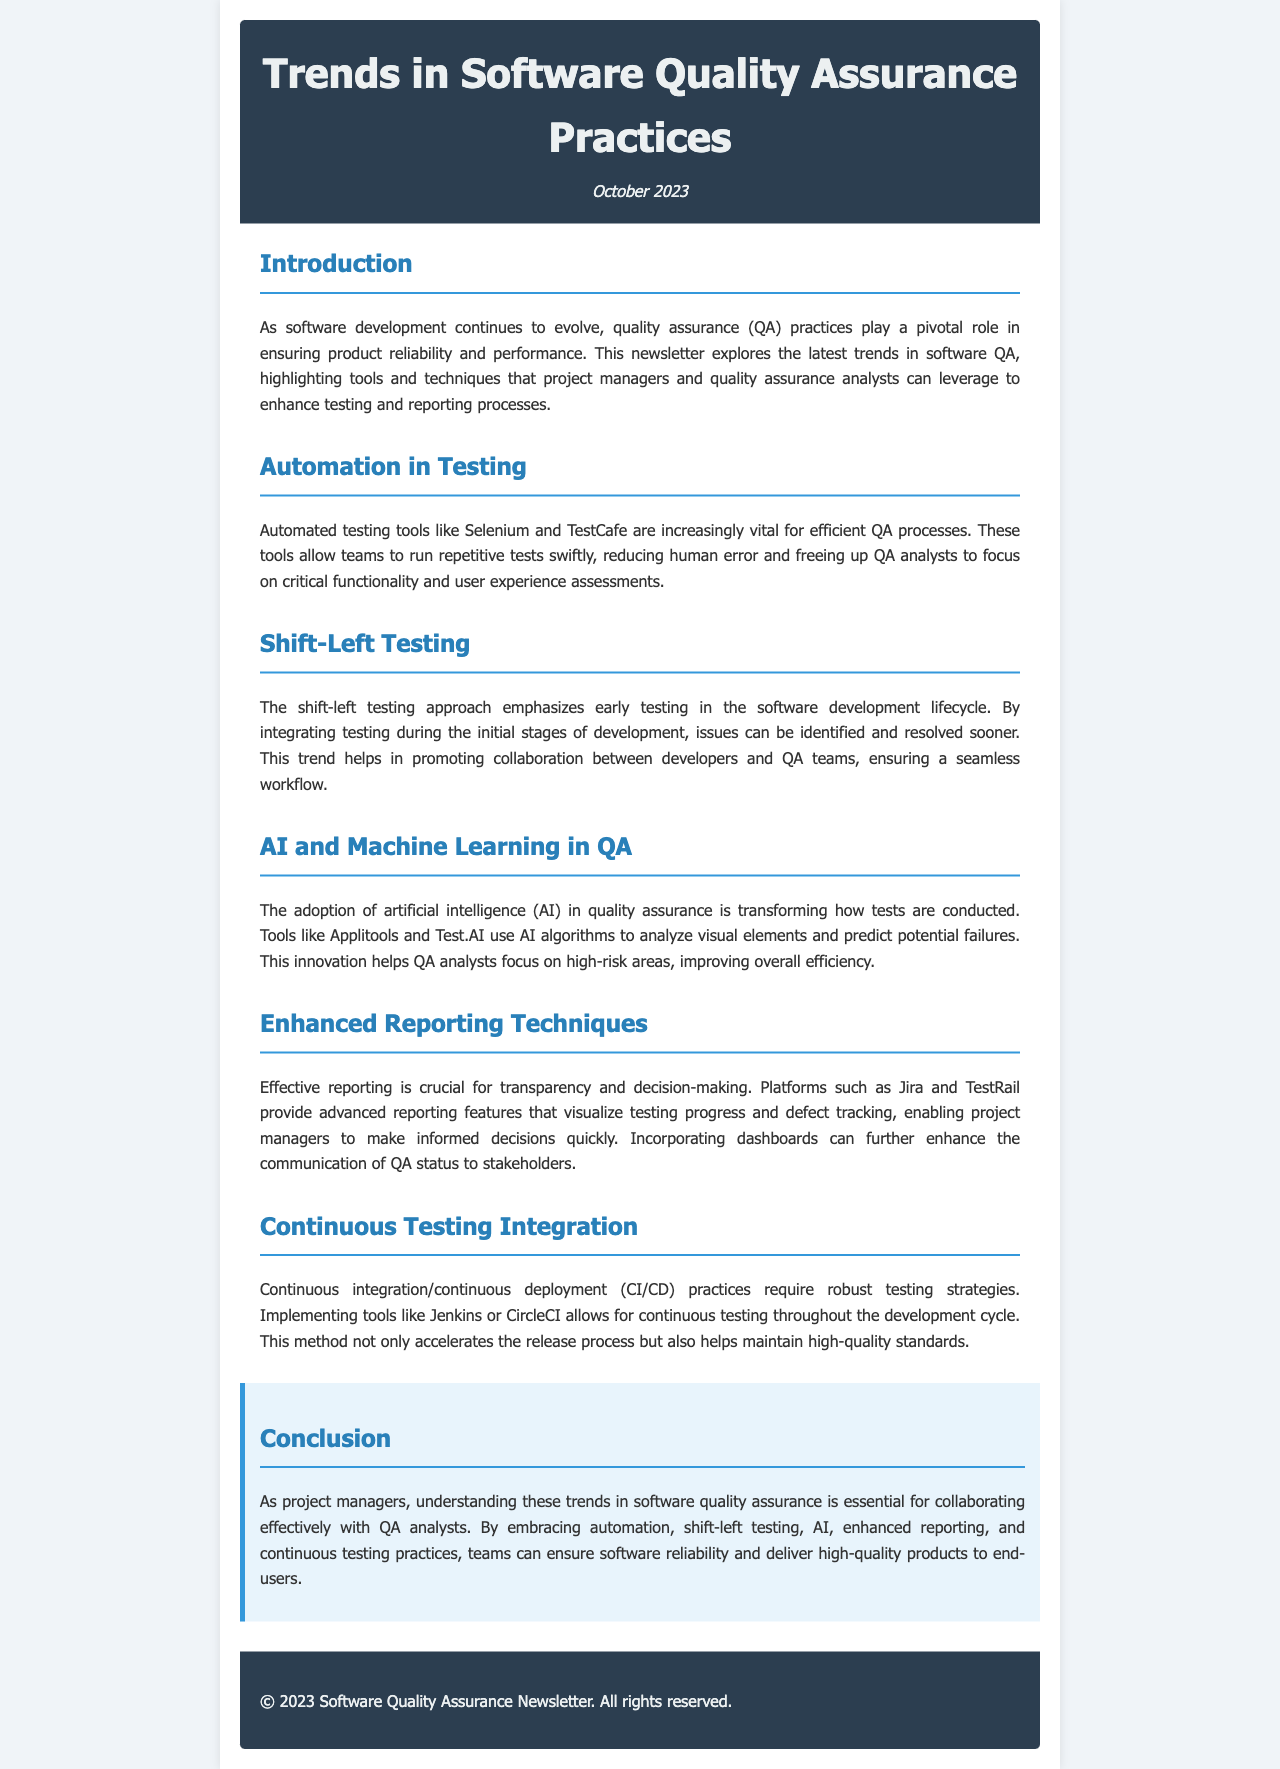What is the title of the newsletter? The title provides the main topic covered in the document, which is "Trends in Software Quality Assurance Practices."
Answer: Trends in Software Quality Assurance Practices When was the newsletter published? The publication date is mentioned in the document as "October 2023."
Answer: October 2023 What testing tools are mentioned for automation? The document lists specific tools that are important for testing automation, namely "Selenium" and "TestCafe."
Answer: Selenium, TestCafe What does the shift-left testing approach emphasize? This approach focuses on early testing in the software development lifecycle according to the document.
Answer: Early testing Which AI tools are highlighted for use in quality assurance? The newsletter specifies tools that utilize AI algorithms, including "Applitools" and "Test.AI."
Answer: Applitools, Test.AI What platforms are noted for enhanced reporting? The document mentions platforms contributing to effective reporting: "Jira" and "TestRail."
Answer: Jira, TestRail Which CI/CD tools allow for continuous testing? The tools identified in the document for continuous testing are "Jenkins" and "CircleCI."
Answer: Jenkins, CircleCI What is essential for collaborating with QA analysts? The conclusion emphasizes understanding of trends in software quality assurance as essential for collaboration.
Answer: Understanding trends What is a key benefit of automated testing? The document states that automated testing reduces human error, benefiting QA processes.
Answer: Reduces human error 